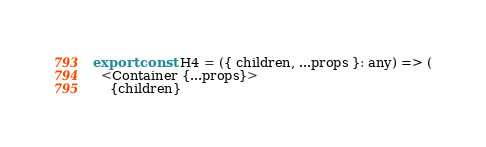<code> <loc_0><loc_0><loc_500><loc_500><_TypeScript_>export const H4 = ({ children, ...props }: any) => (
  <Container {...props}>
    {children}</code> 